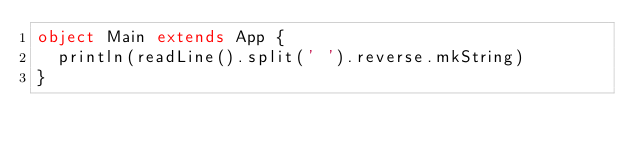<code> <loc_0><loc_0><loc_500><loc_500><_Scala_>object Main extends App {
  println(readLine().split(' ').reverse.mkString)
}</code> 